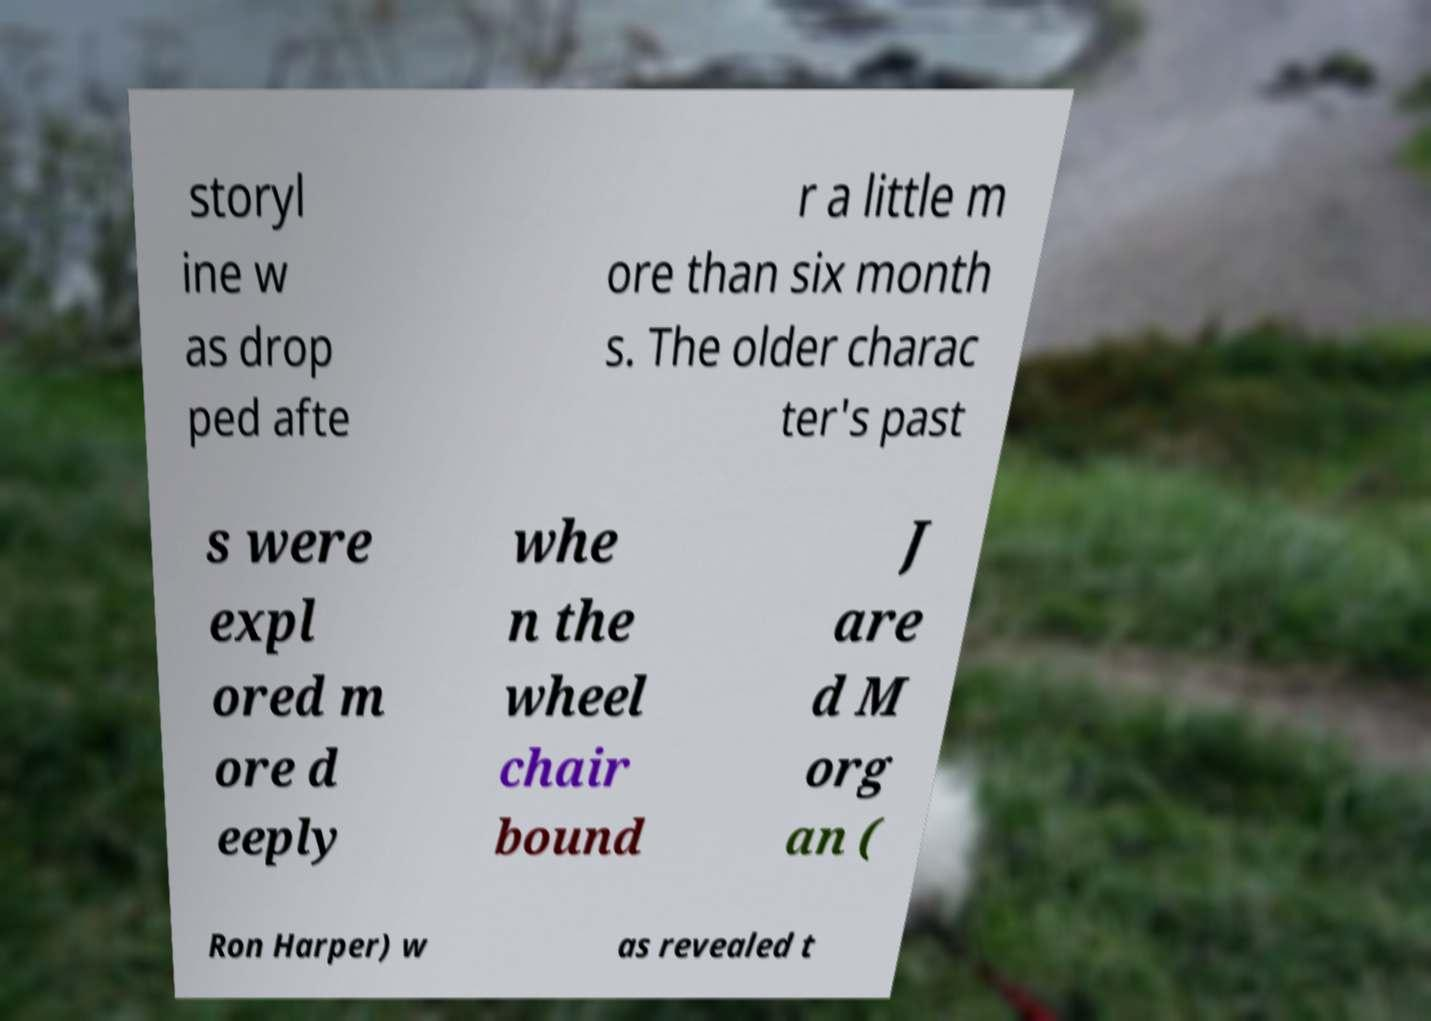Please identify and transcribe the text found in this image. storyl ine w as drop ped afte r a little m ore than six month s. The older charac ter's past s were expl ored m ore d eeply whe n the wheel chair bound J are d M org an ( Ron Harper) w as revealed t 